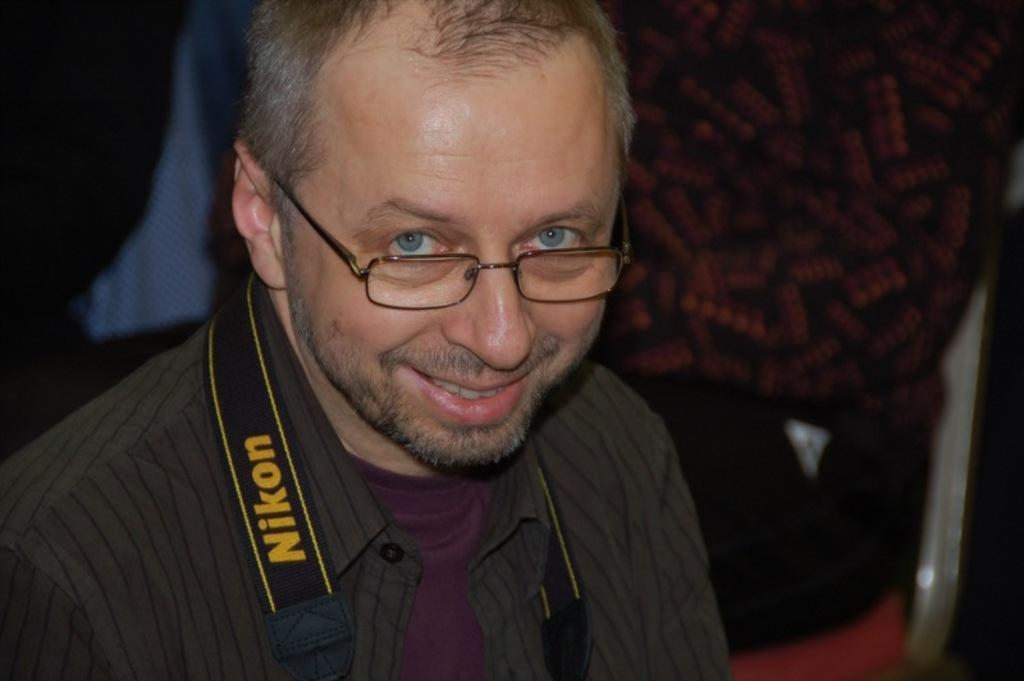Who or what is the main subject of the image? There is a person in the image. Can you describe the person's appearance? The person is wearing clothes and spectacles. What can be observed about the background of the image? The background of the image is blurred. What type of chain can be seen hanging from the person's neck in the image? There is no chain visible in the image; the person is only wearing clothes and spectacles. 